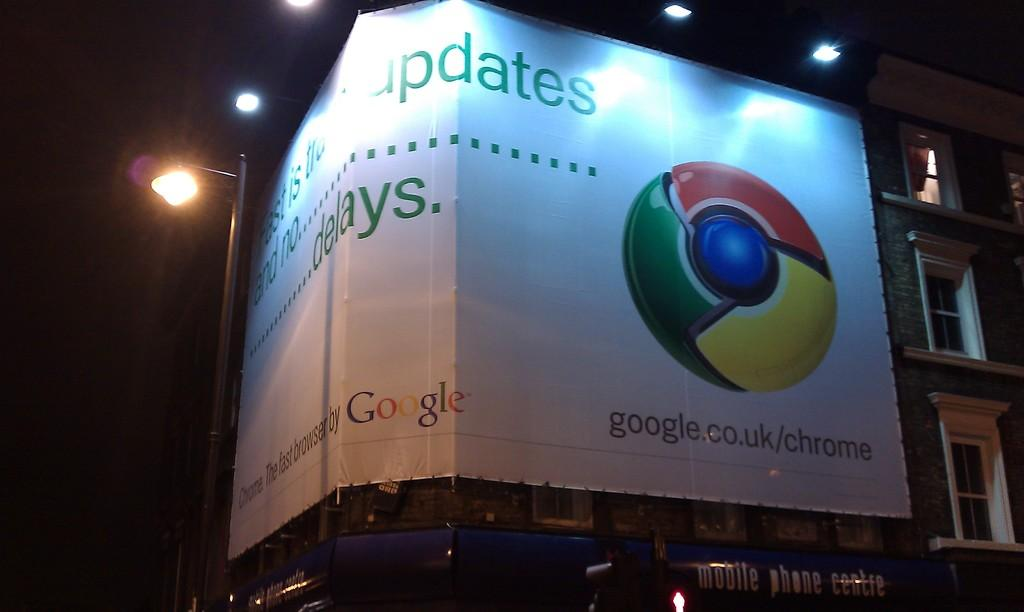<image>
Create a compact narrative representing the image presented. a poster on a building that is for 'google.co.uk/chrome' 